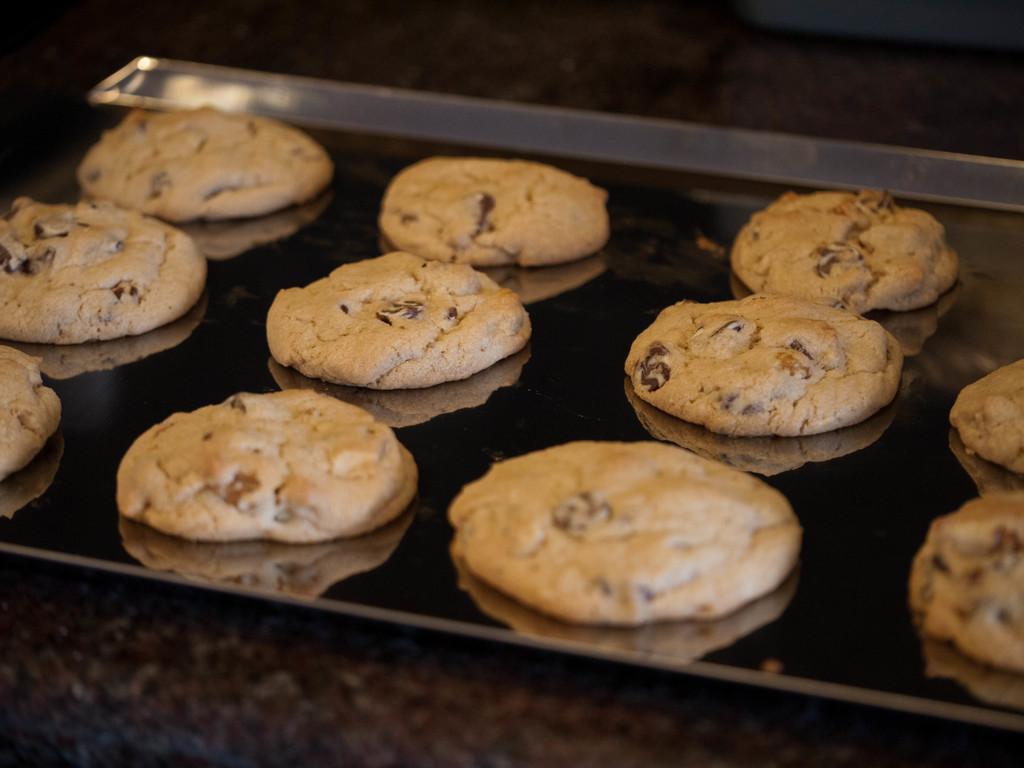Could you give a brief overview of what you see in this image? In this image in the center there is one tray and in that tree there are some cookies, at the bottom it looks like a table. 